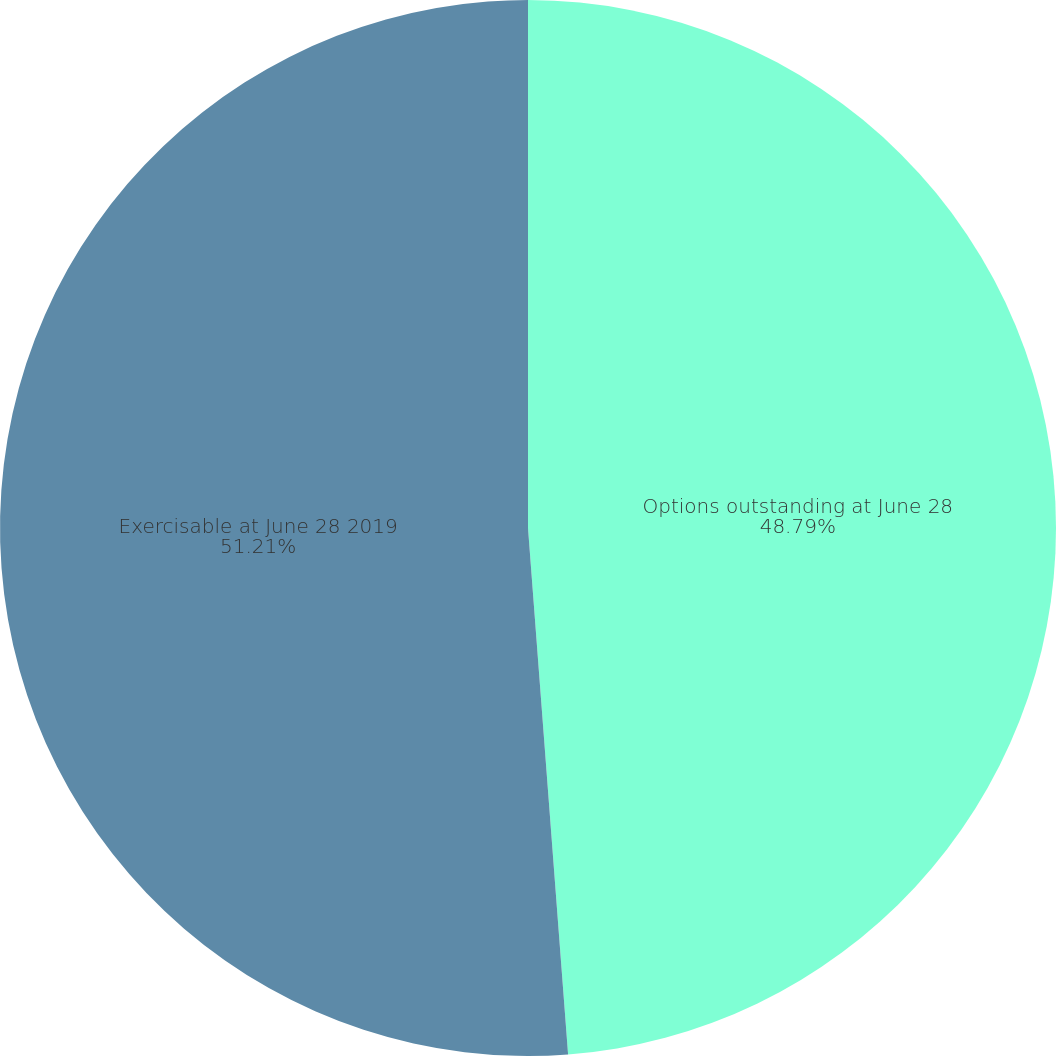Convert chart to OTSL. <chart><loc_0><loc_0><loc_500><loc_500><pie_chart><fcel>Options outstanding at June 28<fcel>Exercisable at June 28 2019<nl><fcel>48.79%<fcel>51.21%<nl></chart> 